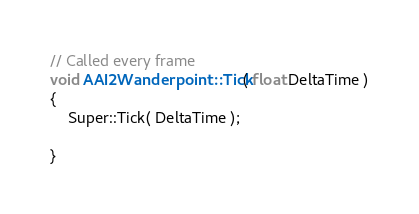<code> <loc_0><loc_0><loc_500><loc_500><_C++_>// Called every frame
void AAI2Wanderpoint::Tick( float DeltaTime )
{
	Super::Tick( DeltaTime );

}

</code> 